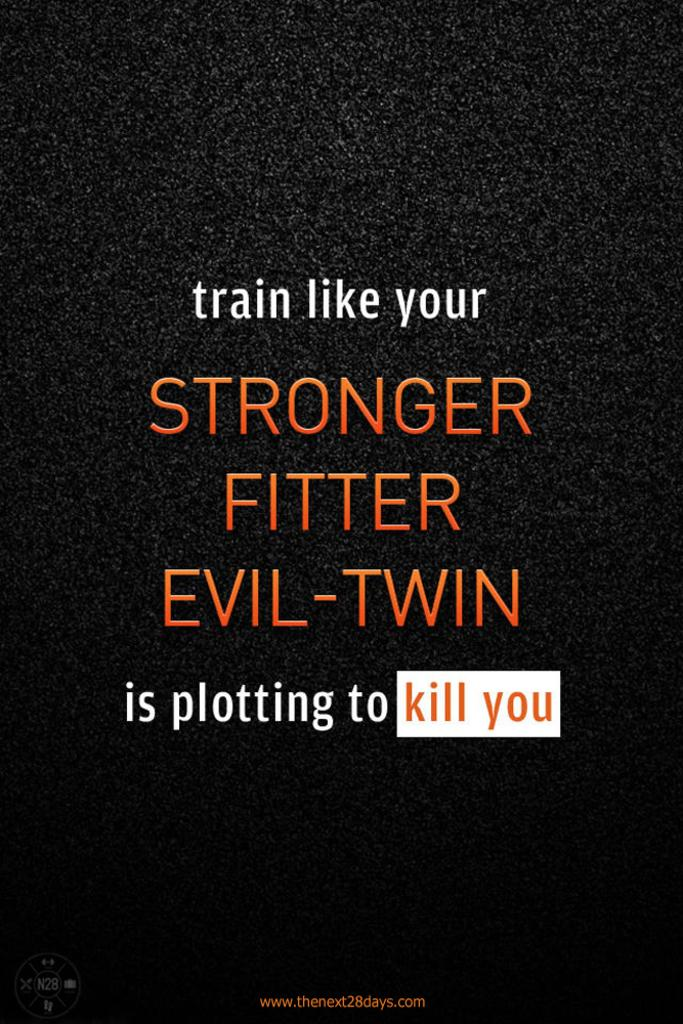<image>
Write a terse but informative summary of the picture. A training message to train like your stronger fitter evil-twin. 